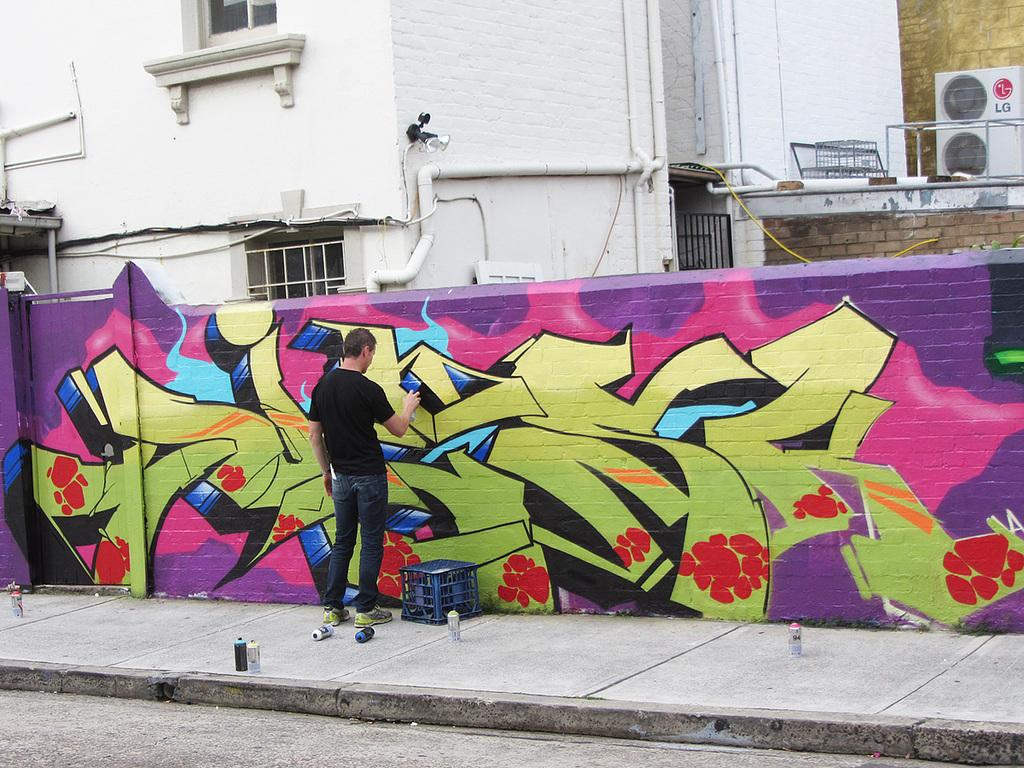What is the person in the image doing? The person in the image is painting on a wall. What is the person using to paint on the wall? The specific tools used for painting are not visible in the image, but the person is clearly applying paint to the wall. What can be seen in the background of the image? There are buildings visible behind the wall. Where is the rabbit hiding in the image? There is no rabbit present in the image. What type of mailbox can be seen near the wall? There is no mailbox visible in the image. 